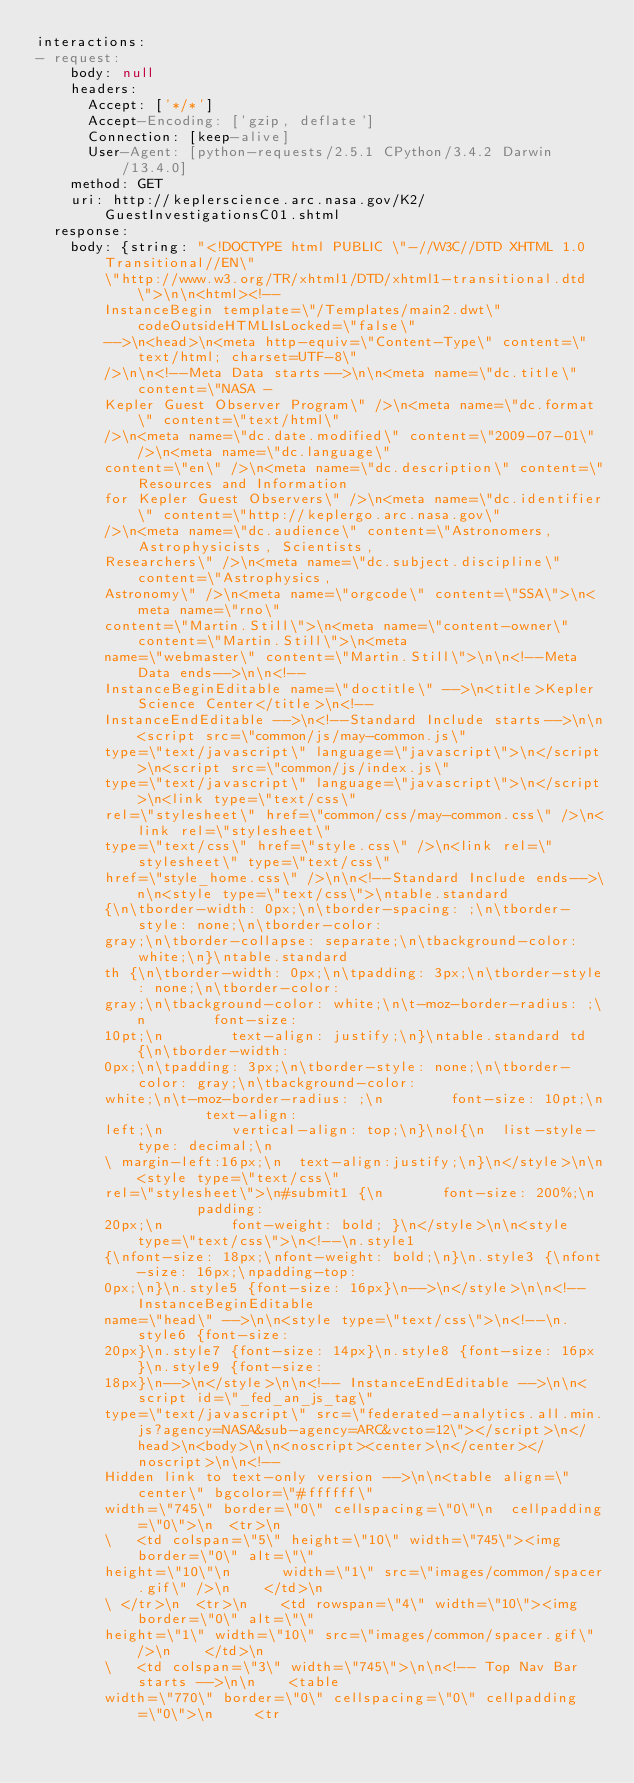<code> <loc_0><loc_0><loc_500><loc_500><_YAML_>interactions:
- request:
    body: null
    headers:
      Accept: ['*/*']
      Accept-Encoding: ['gzip, deflate']
      Connection: [keep-alive]
      User-Agent: [python-requests/2.5.1 CPython/3.4.2 Darwin/13.4.0]
    method: GET
    uri: http://keplerscience.arc.nasa.gov/K2/GuestInvestigationsC01.shtml
  response:
    body: {string: "<!DOCTYPE html PUBLIC \"-//W3C//DTD XHTML 1.0 Transitional//EN\"
        \"http://www.w3.org/TR/xhtml1/DTD/xhtml1-transitional.dtd\">\n\n<html><!--
        InstanceBegin template=\"/Templates/main2.dwt\" codeOutsideHTMLIsLocked=\"false\"
        -->\n<head>\n<meta http-equiv=\"Content-Type\" content=\"text/html; charset=UTF-8\"
        />\n\n<!--Meta Data starts-->\n\n<meta name=\"dc.title\" content=\"NASA -
        Kepler Guest Observer Program\" />\n<meta name=\"dc.format\" content=\"text/html\"
        />\n<meta name=\"dc.date.modified\" content=\"2009-07-01\" />\n<meta name=\"dc.language\"
        content=\"en\" />\n<meta name=\"dc.description\" content=\"Resources and Information
        for Kepler Guest Observers\" />\n<meta name=\"dc.identifier\" content=\"http://keplergo.arc.nasa.gov\"
        />\n<meta name=\"dc.audience\" content=\"Astronomers, Astrophysicists, Scientists,
        Researchers\" />\n<meta name=\"dc.subject.discipline\" content=\"Astrophysics,
        Astronomy\" />\n<meta name=\"orgcode\" content=\"SSA\">\n<meta name=\"rno\"
        content=\"Martin.Still\">\n<meta name=\"content-owner\" content=\"Martin.Still\">\n<meta
        name=\"webmaster\" content=\"Martin.Still\">\n\n<!--Meta Data ends-->\n\n<!--
        InstanceBeginEditable name=\"doctitle\" -->\n<title>Kepler Science Center</title>\n<!--
        InstanceEndEditable -->\n<!--Standard Include starts-->\n\n<script src=\"common/js/may-common.js\"
        type=\"text/javascript\" language=\"javascript\">\n</script>\n<script src=\"common/js/index.js\"
        type=\"text/javascript\" language=\"javascript\">\n</script>\n<link type=\"text/css\"
        rel=\"stylesheet\" href=\"common/css/may-common.css\" />\n<link rel=\"stylesheet\"
        type=\"text/css\" href=\"style.css\" />\n<link rel=\"stylesheet\" type=\"text/css\"
        href=\"style_home.css\" />\n\n<!--Standard Include ends-->\n\n<style type=\"text/css\">\ntable.standard
        {\n\tborder-width: 0px;\n\tborder-spacing: ;\n\tborder-style: none;\n\tborder-color:
        gray;\n\tborder-collapse: separate;\n\tbackground-color: white;\n}\ntable.standard
        th {\n\tborder-width: 0px;\n\tpadding: 3px;\n\tborder-style: none;\n\tborder-color:
        gray;\n\tbackground-color: white;\n\t-moz-border-radius: ;\n        font-size:
        10pt;\n        text-align: justify;\n}\ntable.standard td {\n\tborder-width:
        0px;\n\tpadding: 3px;\n\tborder-style: none;\n\tborder-color: gray;\n\tbackground-color:
        white;\n\t-moz-border-radius: ;\n        font-size: 10pt;\n        text-align:
        left;\n        vertical-align: top;\n}\nol{\n  list-style-type: decimal;\n
        \ margin-left:16px;\n  text-align:justify;\n}\n</style>\n\n<style type=\"text/css\"
        rel=\"stylesheet\">\n#submit1 {\n       font-size: 200%;\n        padding:
        20px;\n        font-weight: bold; }\n</style>\n\n<style type=\"text/css\">\n<!--\n.style1
        {\nfont-size: 18px;\nfont-weight: bold;\n}\n.style3 {\nfont-size: 16px;\npadding-top:
        0px;\n}\n.style5 {font-size: 16px}\n-->\n</style>\n\n<!-- InstanceBeginEditable
        name=\"head\" -->\n\n<style type=\"text/css\">\n<!--\n.style6 {font-size:
        20px}\n.style7 {font-size: 14px}\n.style8 {font-size: 16px}\n.style9 {font-size:
        18px}\n-->\n</style>\n\n<!-- InstanceEndEditable -->\n\n<script id=\"_fed_an_js_tag\"
        type=\"text/javascript\" src=\"federated-analytics.all.min.js?agency=NASA&sub-agency=ARC&vcto=12\"></script>\n</head>\n<body>\n\n<noscript><center>\n</center></noscript>\n\n<!--
        Hidden link to text-only version -->\n\n<table align=\"center\" bgcolor=\"#ffffff\"
        width=\"745\" border=\"0\" cellspacing=\"0\"\n  cellpadding=\"0\">\n  <tr>\n
        \   <td colspan=\"5\" height=\"10\" width=\"745\"><img border=\"0\" alt=\"\"
        height=\"10\"\n      width=\"1\" src=\"images/common/spacer.gif\" />\n    </td>\n
        \ </tr>\n  <tr>\n    <td rowspan=\"4\" width=\"10\"><img border=\"0\" alt=\"\"
        height=\"1\" width=\"10\" src=\"images/common/spacer.gif\" />\n    </td>\n
        \   <td colspan=\"3\" width=\"745\">\n\n<!-- Top Nav Bar starts -->\n\n    <table
        width=\"770\" border=\"0\" cellspacing=\"0\" cellpadding=\"0\">\n     <tr</code> 